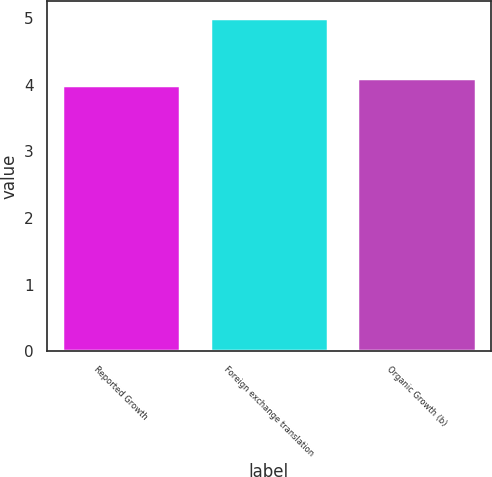Convert chart. <chart><loc_0><loc_0><loc_500><loc_500><bar_chart><fcel>Reported Growth<fcel>Foreign exchange translation<fcel>Organic Growth (b)<nl><fcel>4<fcel>5<fcel>4.1<nl></chart> 